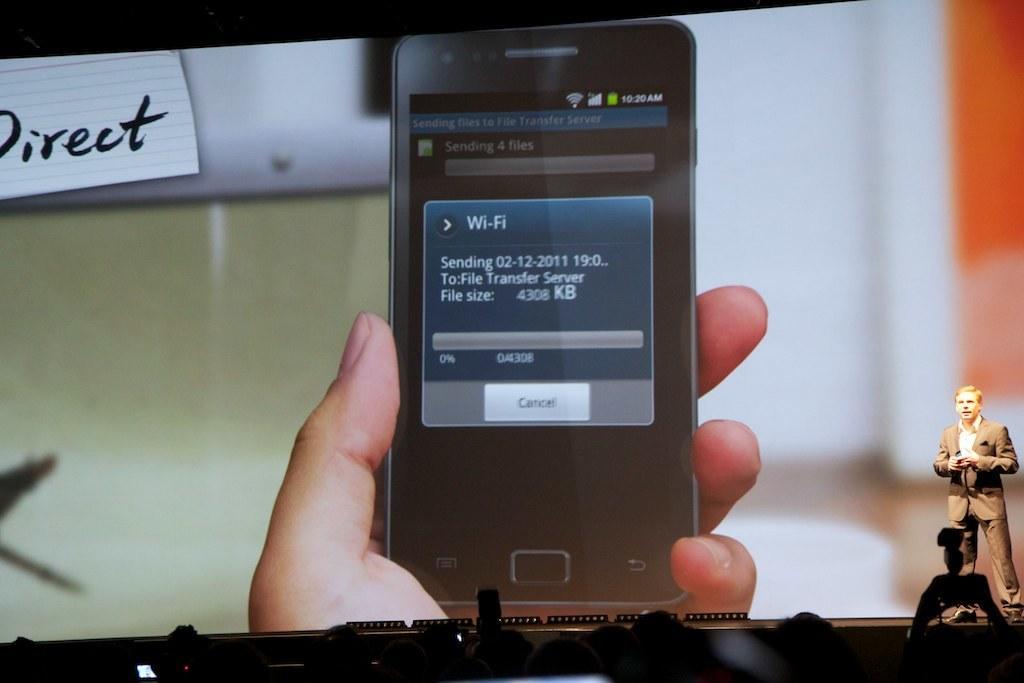Can you describe this image briefly? In the image there is a man standing on the dais and behind him there is a screen, it is displaying a mobile phone and in front of the days there is a crowd. 